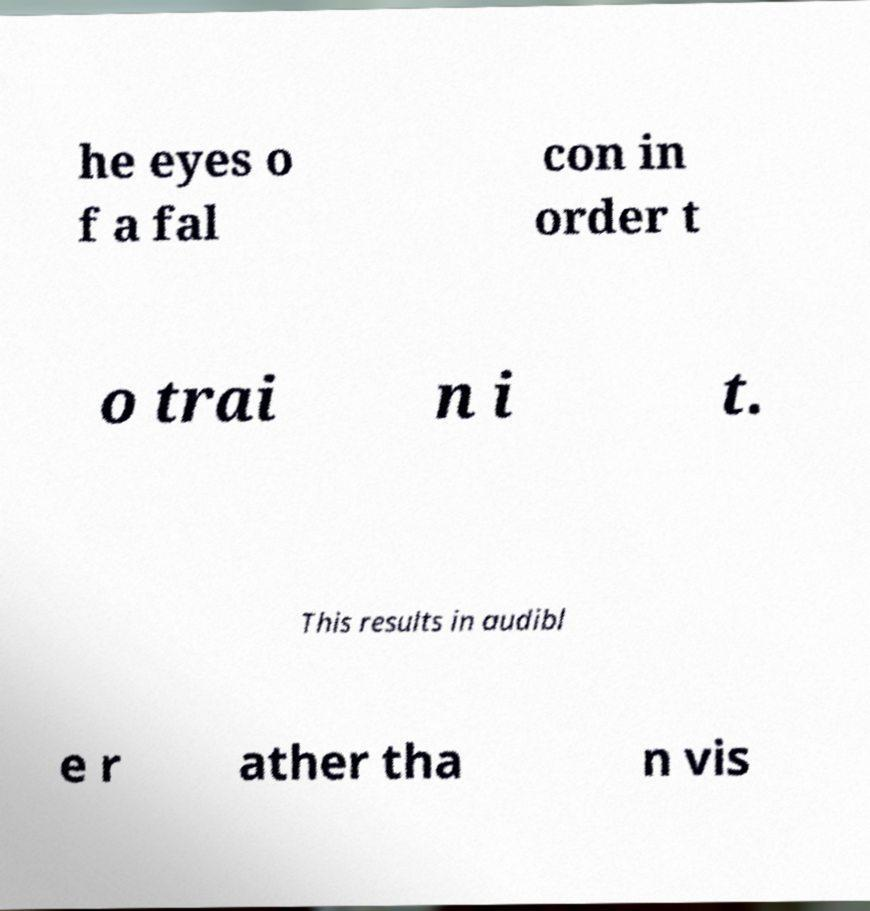Please identify and transcribe the text found in this image. he eyes o f a fal con in order t o trai n i t. This results in audibl e r ather tha n vis 